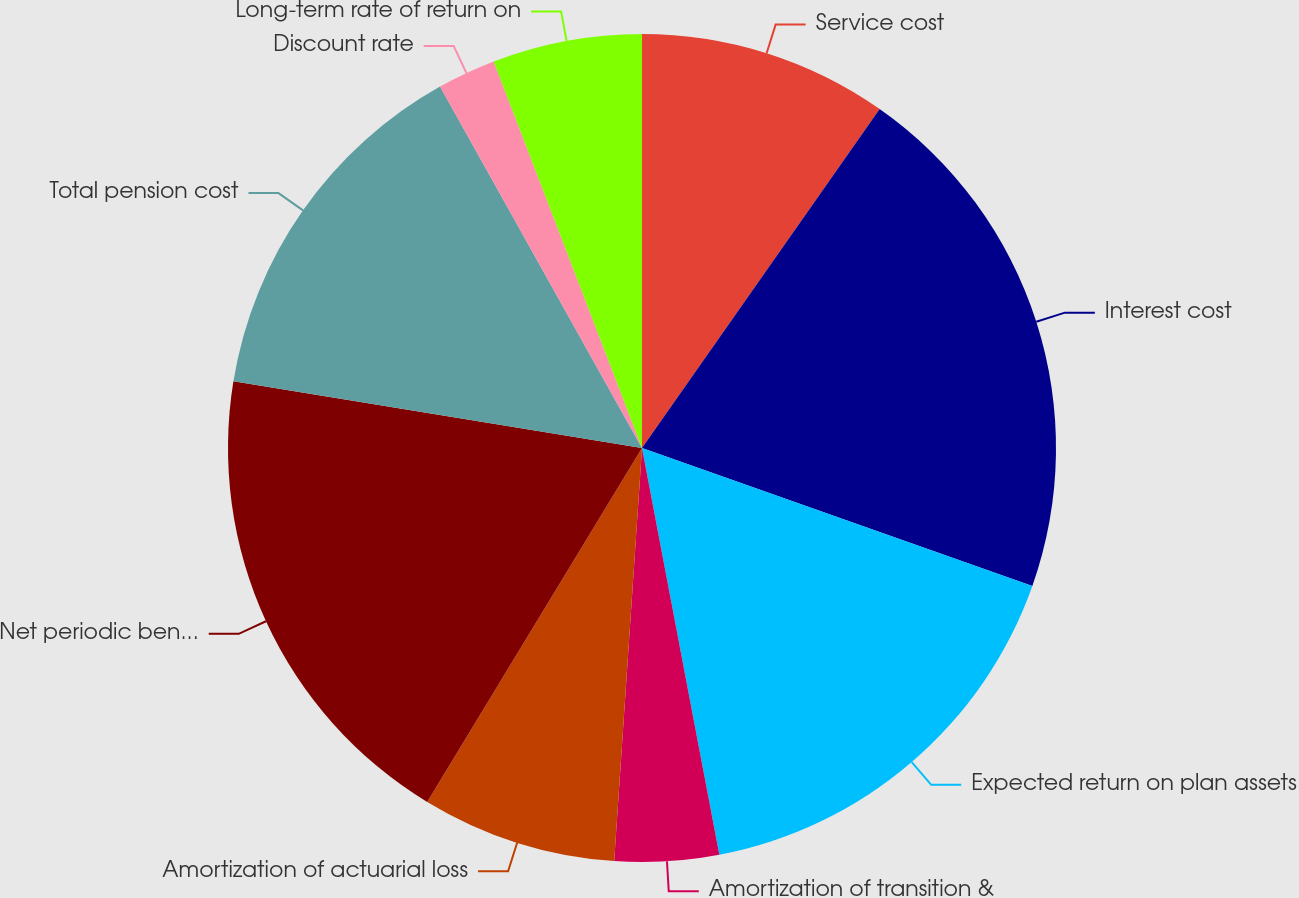Convert chart. <chart><loc_0><loc_0><loc_500><loc_500><pie_chart><fcel>Service cost<fcel>Interest cost<fcel>Expected return on plan assets<fcel>Amortization of transition &<fcel>Amortization of actuarial loss<fcel>Net periodic benefit cost<fcel>Total pension cost<fcel>Discount rate<fcel>Long-term rate of return on<nl><fcel>9.73%<fcel>20.67%<fcel>16.6%<fcel>4.06%<fcel>7.61%<fcel>18.89%<fcel>14.31%<fcel>2.28%<fcel>5.83%<nl></chart> 